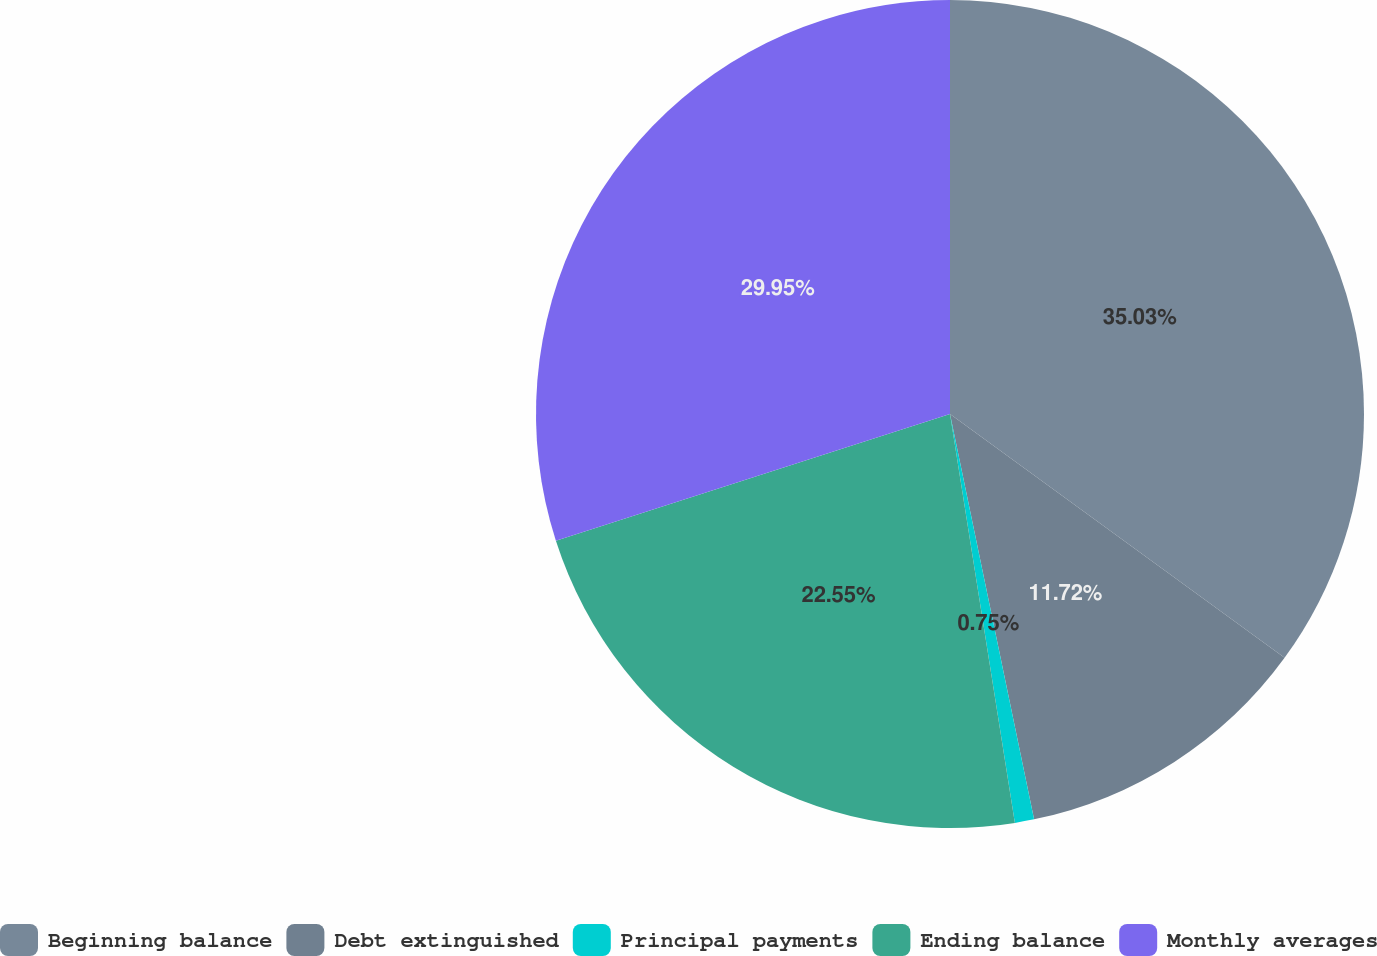Convert chart. <chart><loc_0><loc_0><loc_500><loc_500><pie_chart><fcel>Beginning balance<fcel>Debt extinguished<fcel>Principal payments<fcel>Ending balance<fcel>Monthly averages<nl><fcel>35.02%<fcel>11.72%<fcel>0.75%<fcel>22.55%<fcel>29.95%<nl></chart> 